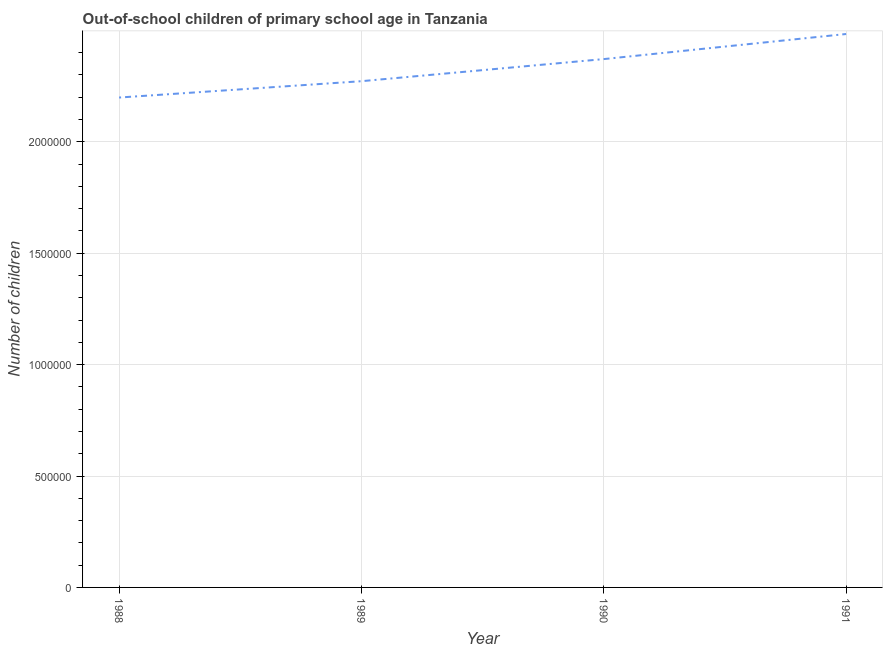What is the number of out-of-school children in 1990?
Provide a succinct answer. 2.37e+06. Across all years, what is the maximum number of out-of-school children?
Your answer should be very brief. 2.48e+06. Across all years, what is the minimum number of out-of-school children?
Provide a succinct answer. 2.20e+06. What is the sum of the number of out-of-school children?
Offer a very short reply. 9.32e+06. What is the difference between the number of out-of-school children in 1989 and 1990?
Provide a succinct answer. -9.92e+04. What is the average number of out-of-school children per year?
Give a very brief answer. 2.33e+06. What is the median number of out-of-school children?
Make the answer very short. 2.32e+06. In how many years, is the number of out-of-school children greater than 300000 ?
Offer a terse response. 4. What is the ratio of the number of out-of-school children in 1988 to that in 1990?
Your answer should be very brief. 0.93. Is the number of out-of-school children in 1988 less than that in 1989?
Keep it short and to the point. Yes. Is the difference between the number of out-of-school children in 1988 and 1990 greater than the difference between any two years?
Provide a succinct answer. No. What is the difference between the highest and the second highest number of out-of-school children?
Provide a short and direct response. 1.13e+05. Is the sum of the number of out-of-school children in 1989 and 1990 greater than the maximum number of out-of-school children across all years?
Your answer should be compact. Yes. What is the difference between the highest and the lowest number of out-of-school children?
Give a very brief answer. 2.85e+05. How many lines are there?
Give a very brief answer. 1. What is the difference between two consecutive major ticks on the Y-axis?
Your answer should be very brief. 5.00e+05. Are the values on the major ticks of Y-axis written in scientific E-notation?
Your answer should be very brief. No. Does the graph contain grids?
Your answer should be compact. Yes. What is the title of the graph?
Give a very brief answer. Out-of-school children of primary school age in Tanzania. What is the label or title of the X-axis?
Keep it short and to the point. Year. What is the label or title of the Y-axis?
Make the answer very short. Number of children. What is the Number of children of 1988?
Your answer should be very brief. 2.20e+06. What is the Number of children of 1989?
Provide a short and direct response. 2.27e+06. What is the Number of children of 1990?
Keep it short and to the point. 2.37e+06. What is the Number of children in 1991?
Offer a terse response. 2.48e+06. What is the difference between the Number of children in 1988 and 1989?
Ensure brevity in your answer.  -7.34e+04. What is the difference between the Number of children in 1988 and 1990?
Your answer should be compact. -1.73e+05. What is the difference between the Number of children in 1988 and 1991?
Your answer should be very brief. -2.85e+05. What is the difference between the Number of children in 1989 and 1990?
Make the answer very short. -9.92e+04. What is the difference between the Number of children in 1989 and 1991?
Your answer should be very brief. -2.12e+05. What is the difference between the Number of children in 1990 and 1991?
Offer a very short reply. -1.13e+05. What is the ratio of the Number of children in 1988 to that in 1990?
Keep it short and to the point. 0.93. What is the ratio of the Number of children in 1988 to that in 1991?
Your answer should be very brief. 0.89. What is the ratio of the Number of children in 1989 to that in 1990?
Your response must be concise. 0.96. What is the ratio of the Number of children in 1989 to that in 1991?
Make the answer very short. 0.92. What is the ratio of the Number of children in 1990 to that in 1991?
Provide a succinct answer. 0.95. 